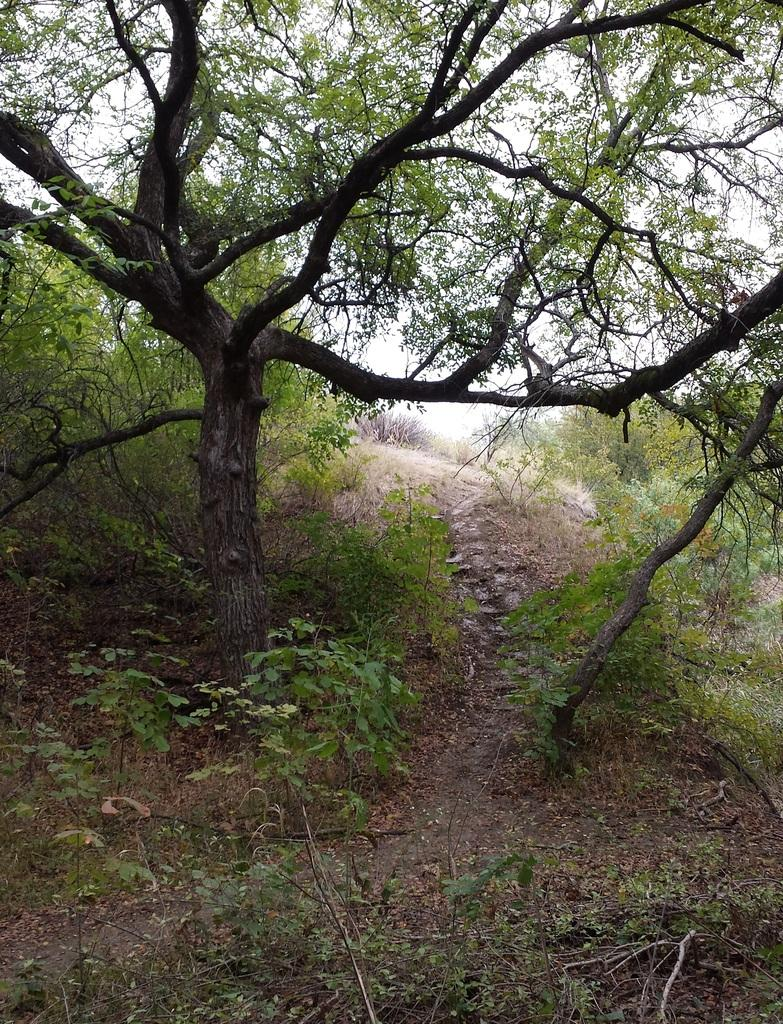What can be seen in the background of the image? The sky is visible in the background of the image. What type of vegetation is present in the image? There are trees and plants in the image. What might be the setting of the image? The image appears to depict a forest area. What type of attraction is present in the image? There is no attraction present in the image; it depicts a forest area with trees and plants. 